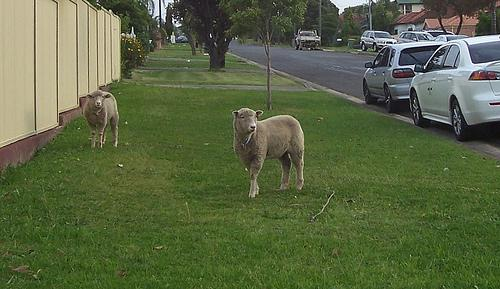Enumerate the different types of vehicles present in the image and their general location. There is a white car, parked cars, and a truck on the side of the street, all located towards the right side of the image. Describe the overall setting of the image in a concise manner. The image depicts a street scene with sheep on grass, parked cars, trees, and houses in the background. Briefly describe the appearance and location of the animals in the image. There are two white sheep standing on the side of the road on short green grass located towards the left side of the image. Combining the natural and human-made elements in the image, give a brief overview of the scene. The scene includes sheep grazing on grass, cars parked by the street, trees in the background, and Homes along the street. In simple words, describe the main components of the image, giving more importance to living beings. The image has white sheep on green grass, cars parked on a street, and houses surrounded by trees in the background. Highlight the significant elements related to nature in the image. There are trees in the background, green grass on the ground, and a flowering bush growing on the grassy area. Mention the most dominant objects in the image along with their positions. Two white sheep are on short grass near the left side, while a white car and parked cars are on the right side of the image. Summarize the major components of the image in a single sentence. The image portrays white sheep on grass, vehicles parked along a street, and houses with trees in the background. Mention the most important elements related to human settlement in the image. The image features houses in the background, cars parked on the side of the road, and a trash can standing out by the street. Describe the props of the road in the scene. The road has a curb along the side, blacktop surface, and various cars parked, including a white car and a truck. 